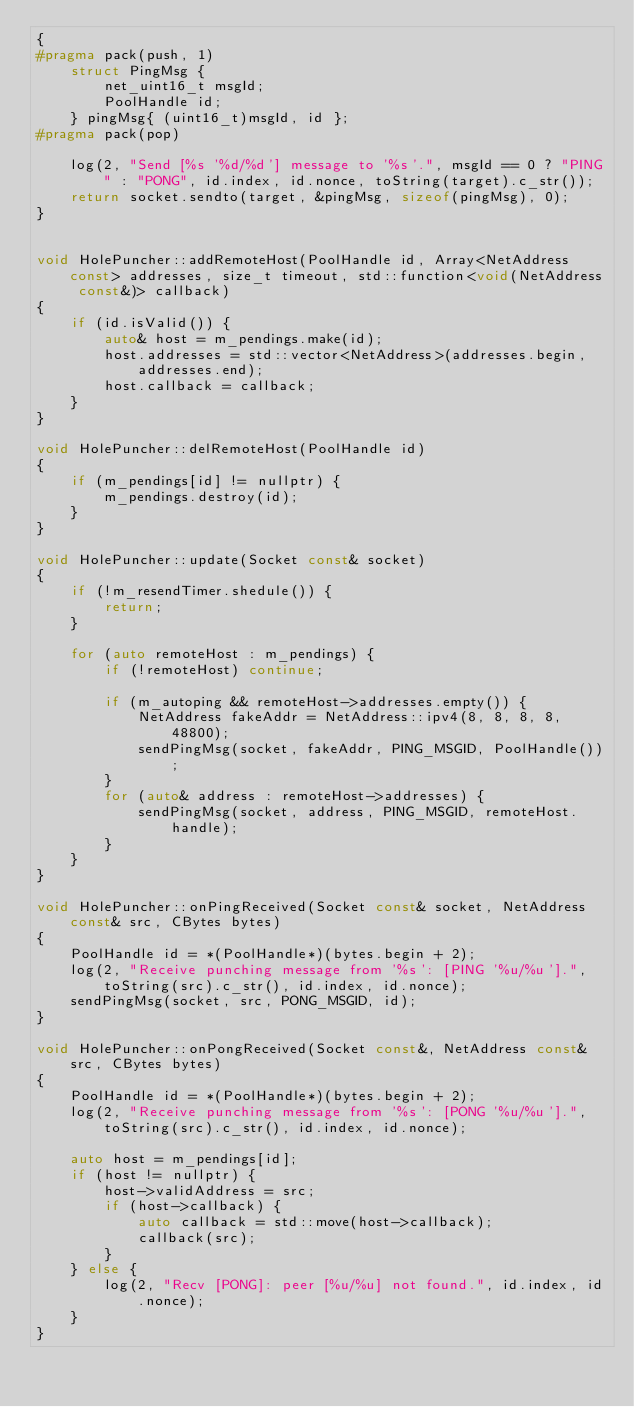Convert code to text. <code><loc_0><loc_0><loc_500><loc_500><_C++_>{
#pragma pack(push, 1)
	struct PingMsg {
		net_uint16_t msgId;
		PoolHandle id;
	} pingMsg{ (uint16_t)msgId, id };
#pragma pack(pop)

	log(2, "Send [%s '%d/%d'] message to '%s'.", msgId == 0 ? "PING" : "PONG", id.index, id.nonce, toString(target).c_str());
	return socket.sendto(target, &pingMsg, sizeof(pingMsg), 0);
}


void HolePuncher::addRemoteHost(PoolHandle id, Array<NetAddress const> addresses, size_t timeout, std::function<void(NetAddress const&)> callback)
{
	if (id.isValid()) {
		auto& host = m_pendings.make(id);
		host.addresses = std::vector<NetAddress>(addresses.begin, addresses.end);
		host.callback = callback;
	}
}

void HolePuncher::delRemoteHost(PoolHandle id)
{
	if (m_pendings[id] != nullptr) {
		m_pendings.destroy(id);
	}
}

void HolePuncher::update(Socket const& socket)
{
	if (!m_resendTimer.shedule()) {
		return;
	}

	for (auto remoteHost : m_pendings) {
		if (!remoteHost) continue;

		if (m_autoping && remoteHost->addresses.empty()) {
			NetAddress fakeAddr = NetAddress::ipv4(8, 8, 8, 8, 48800);
			sendPingMsg(socket, fakeAddr, PING_MSGID, PoolHandle());
		}
		for (auto& address : remoteHost->addresses) {
			sendPingMsg(socket, address, PING_MSGID, remoteHost.handle);
		}
	}
}

void HolePuncher::onPingReceived(Socket const& socket, NetAddress const& src, CBytes bytes)
{
	PoolHandle id = *(PoolHandle*)(bytes.begin + 2);
	log(2, "Receive punching message from '%s': [PING '%u/%u'].", toString(src).c_str(), id.index, id.nonce);
	sendPingMsg(socket, src, PONG_MSGID, id);
}

void HolePuncher::onPongReceived(Socket const&, NetAddress const& src, CBytes bytes)
{
	PoolHandle id = *(PoolHandle*)(bytes.begin + 2);
	log(2, "Receive punching message from '%s': [PONG '%u/%u'].", toString(src).c_str(), id.index, id.nonce);

	auto host = m_pendings[id];
	if (host != nullptr) {
		host->validAddress = src;
		if (host->callback) {
			auto callback = std::move(host->callback);
			callback(src);
		}
	} else {
		log(2, "Recv [PONG]: peer [%u/%u] not found.", id.index, id.nonce);
	}
}</code> 